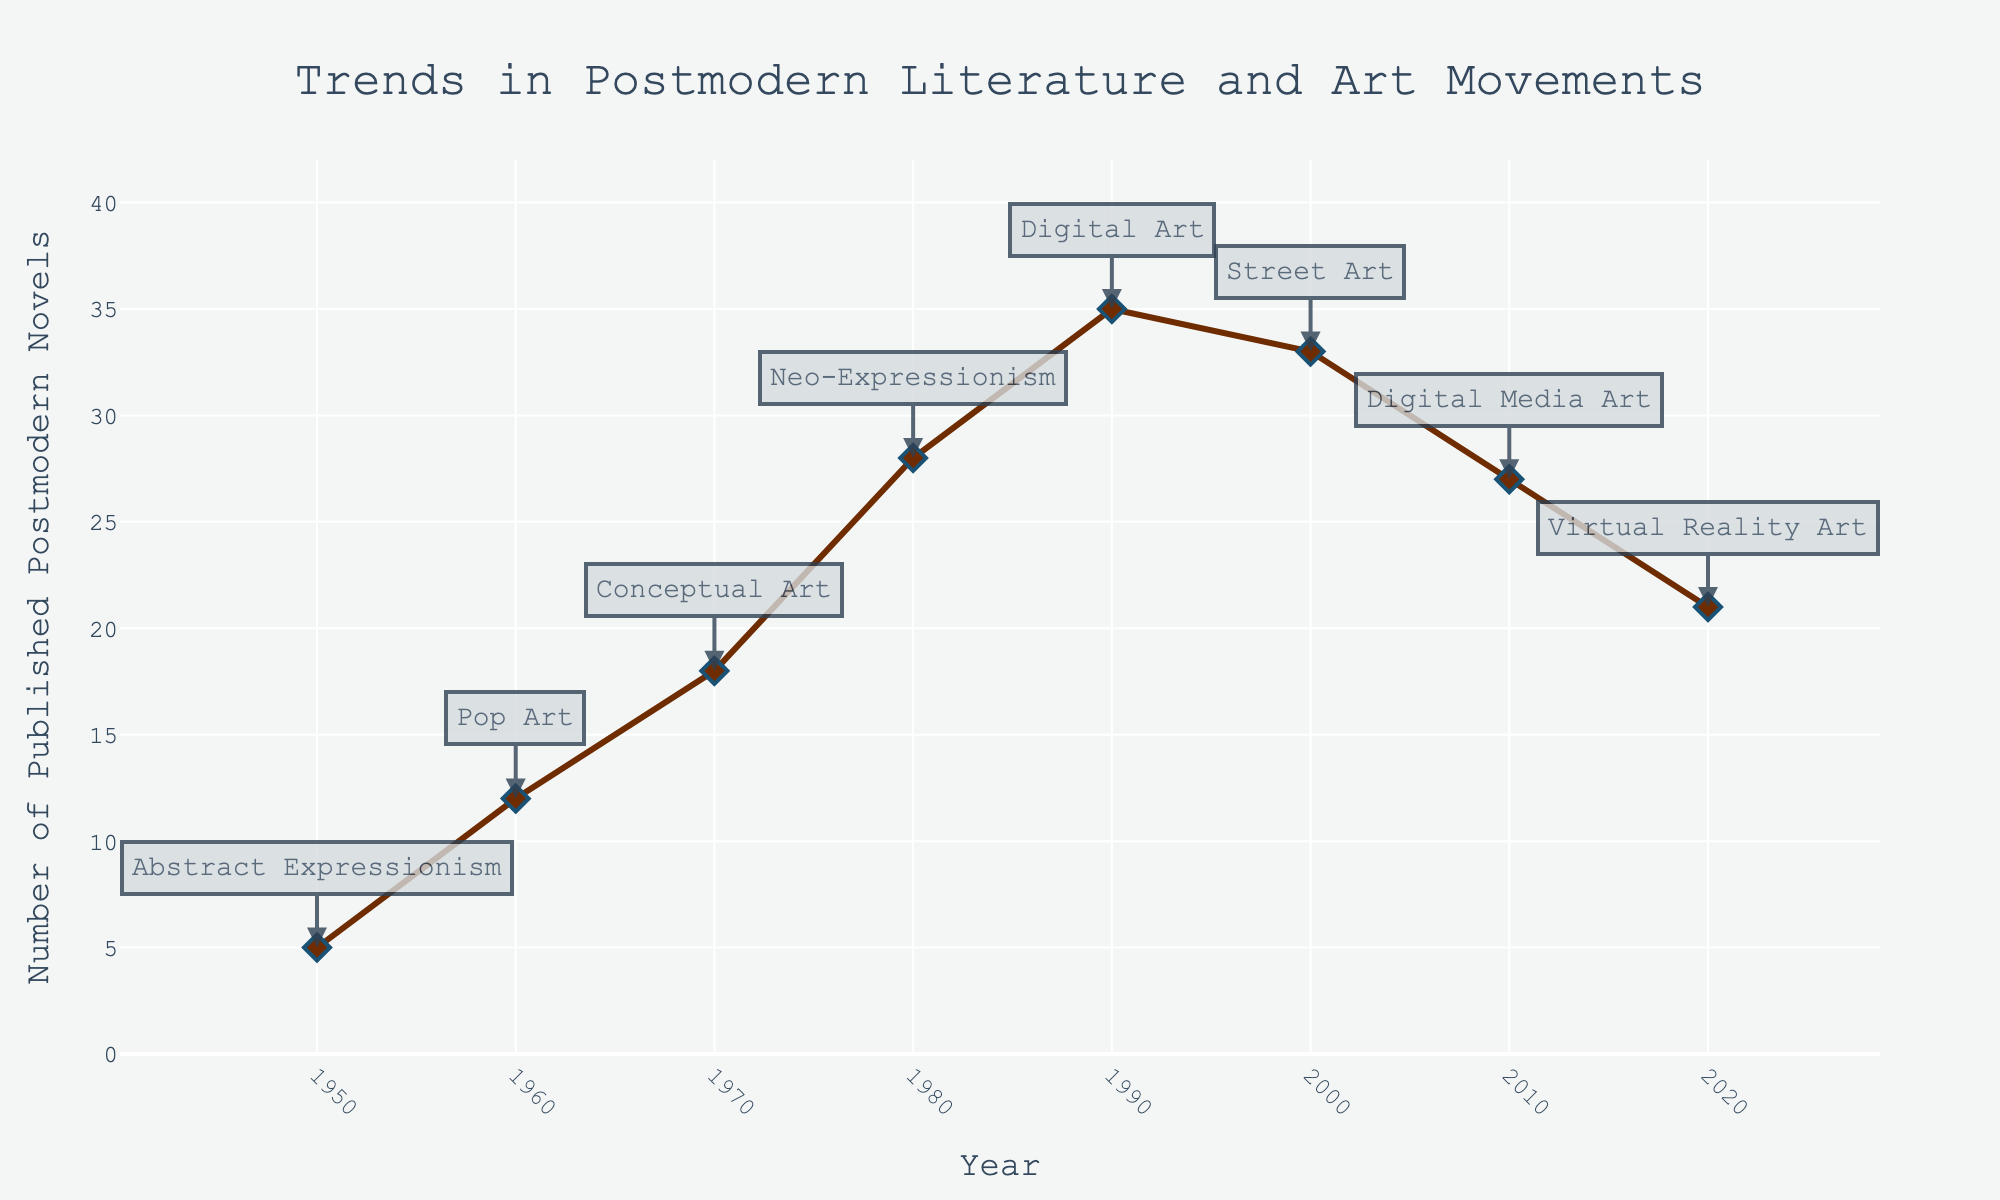What is the title of the plot? The title is usually displayed at the top of the plot. In this case, it reads "Trends in Postmodern Literature and Art Movements".
Answer: Trends in Postmodern Literature and Art Movements During which decade were the most postmodern novels published? By examining the y-axis values across the plot, the peak number of published postmodern novels appears in the 1990s.
Answer: 1990s What was the art movement influenced by postmodern novels in the 1970s? The annotations with each data point show the corresponding art movements. For the 1970s, it is listed as "Conceptual Art".
Answer: Conceptual Art How many postmodern novels were published in 2000? Look at the point corresponding to the year 2000 on the x-axis and trace it up to the y-axis. The point indicates 33 novels.
Answer: 33 Which recent art form was influenced by postmodern novels in 2020? The annotations for the year 2020 indicate the art movement as "Virtual Reality Art".
Answer: Virtual Reality Art What is the general trend in the number of postmodern novels published from 1950 to 2020? The trend can be seen by following the line from 1950 to 2020, showing an increase peaking around 1990 and then a gradual decline.
Answer: Increasing then Decreasing What's the difference in the number of published postmodern novels between 1980 and 2020? The plot shows 28 novels in 1980 and 21 novels in 2020. The difference is 28 - 21 = 7.
Answer: 7 Compare the number of published postmodern novels in 1960 and 1970. Which year had more publications, and by how many more? In 1960, there were 12 novels; in 1970, there were 18. So, 18 - 12 = 6 more novels in 1970.
Answer: 1970 by 6 What pattern is observed in the postmodern novels publication trend throughout the decades? The pattern shows a steady increase from 1950, peaking in the 1990s, followed by a decline into 2020.
Answer: Steady increase then decline Which art movement is associated with the year in which postmodern novels publication peaked? The highest number of postmodern novels were published in 1990, associated with "Digital Art".
Answer: Digital Art 